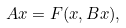Convert formula to latex. <formula><loc_0><loc_0><loc_500><loc_500>A x = F ( x , B x ) ,</formula> 